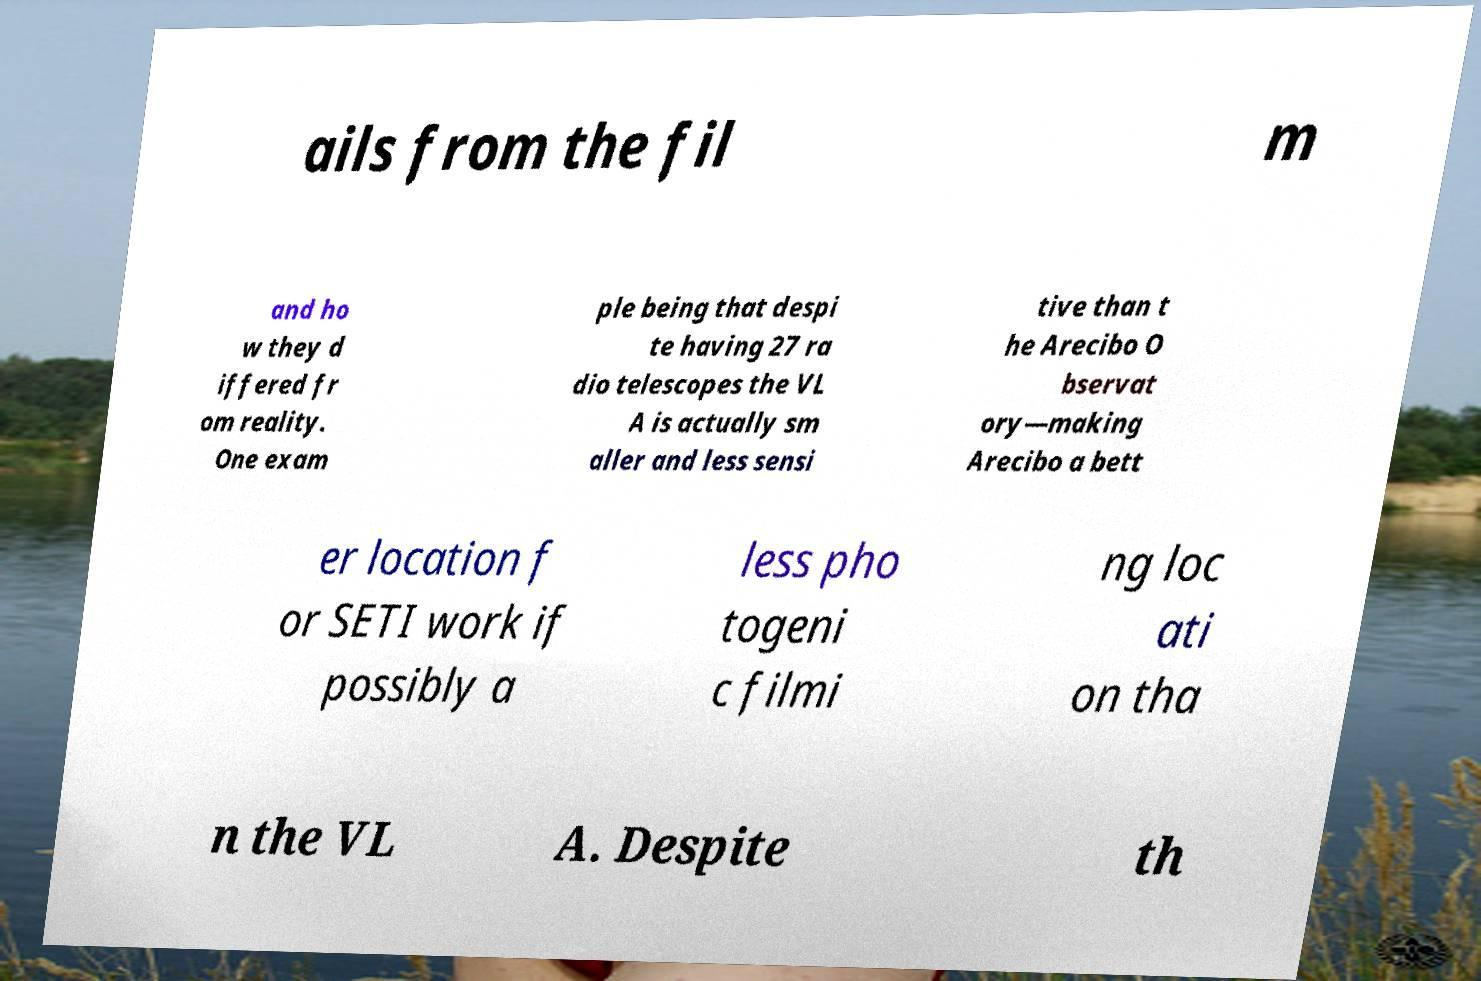Can you accurately transcribe the text from the provided image for me? ails from the fil m and ho w they d iffered fr om reality. One exam ple being that despi te having 27 ra dio telescopes the VL A is actually sm aller and less sensi tive than t he Arecibo O bservat ory—making Arecibo a bett er location f or SETI work if possibly a less pho togeni c filmi ng loc ati on tha n the VL A. Despite th 